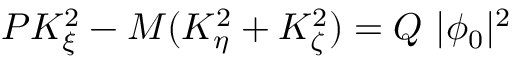Convert formula to latex. <formula><loc_0><loc_0><loc_500><loc_500>P K _ { \xi } ^ { 2 } - M ( K _ { \eta } ^ { 2 } + K _ { \zeta } ^ { 2 } ) = Q | \phi _ { 0 } | ^ { 2 }</formula> 